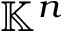<formula> <loc_0><loc_0><loc_500><loc_500>\mathbb { K } ^ { n }</formula> 